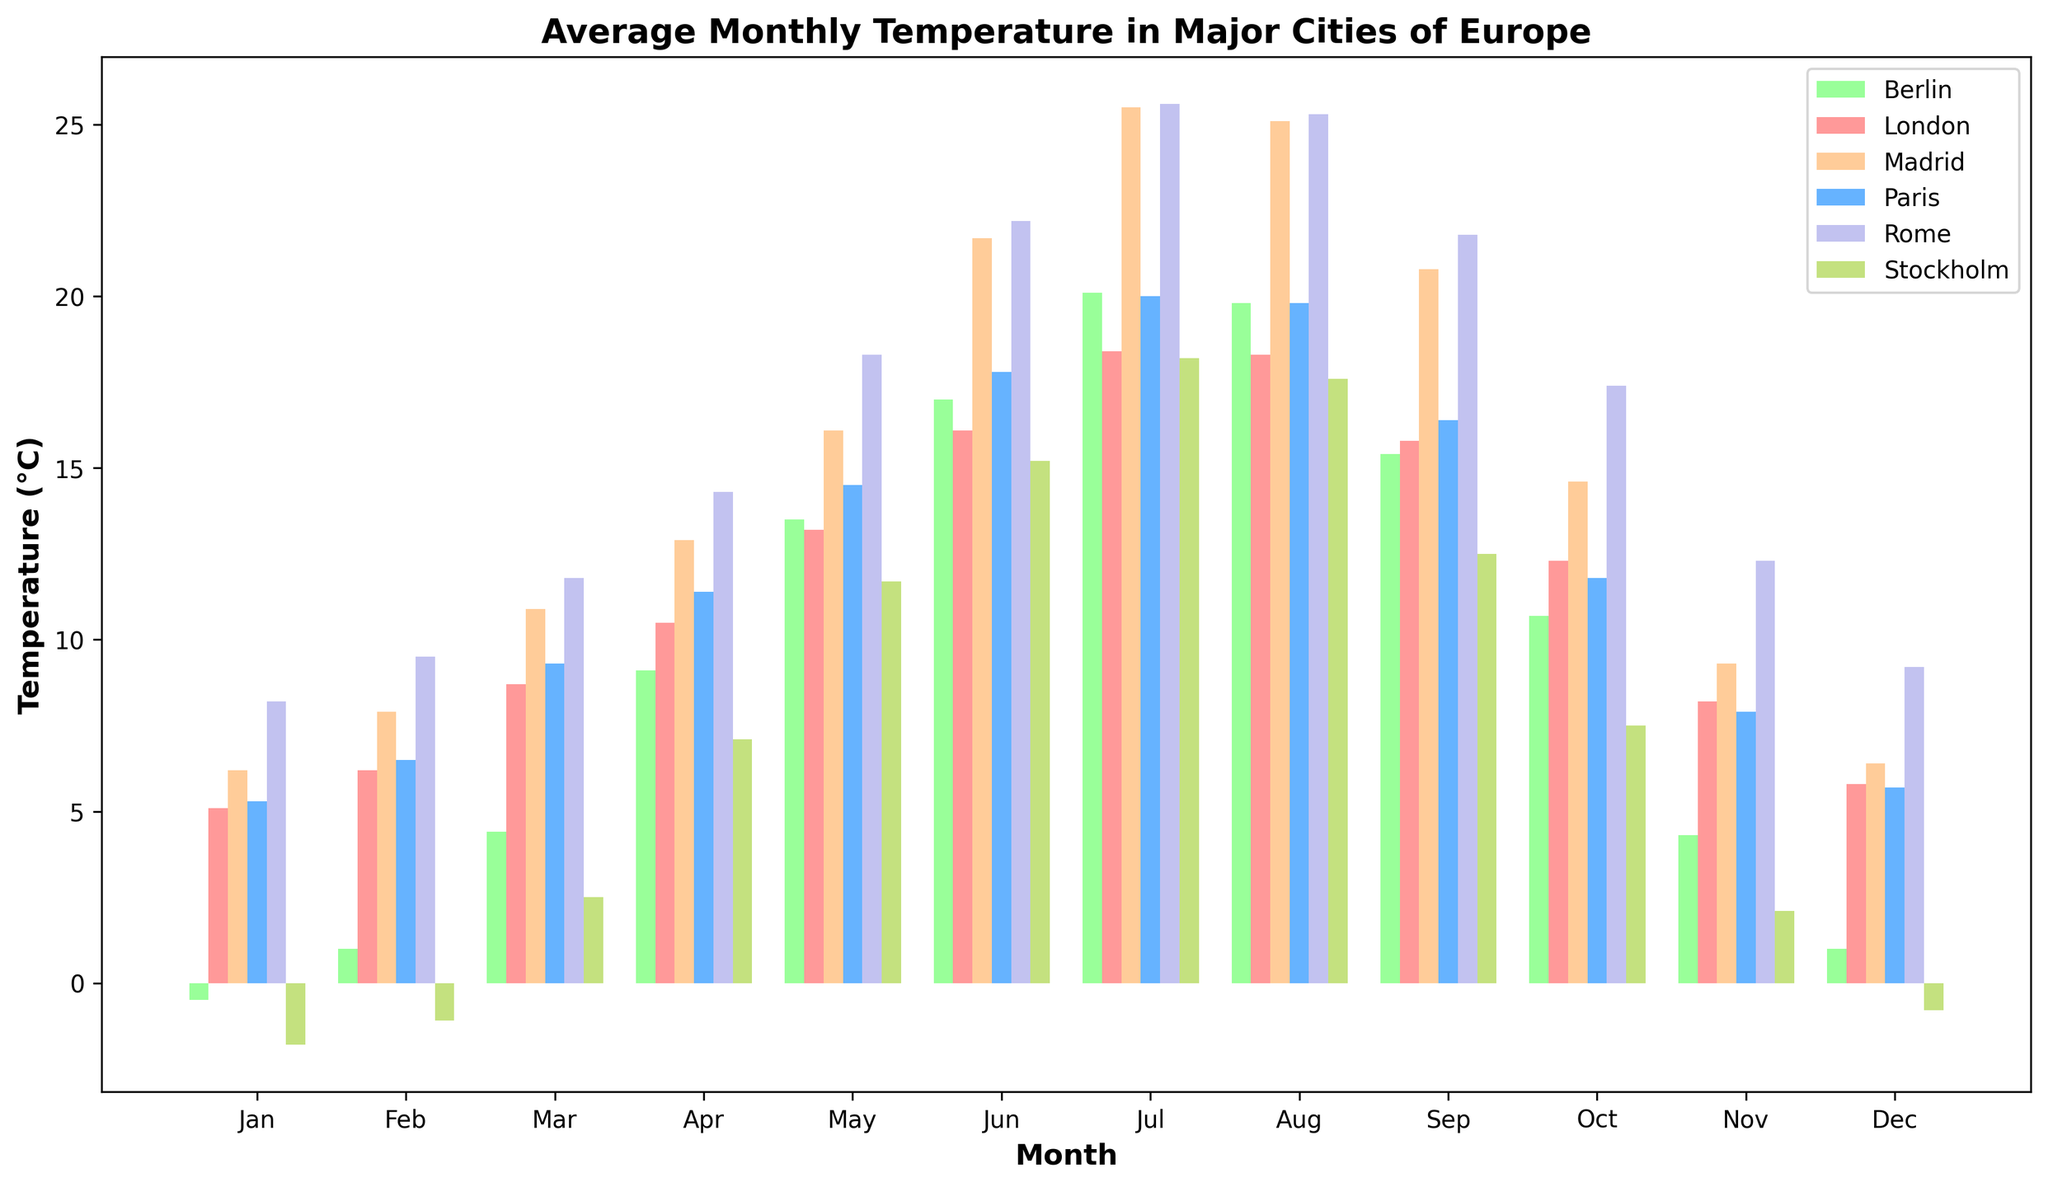What is the average temperature for Paris in the summer months (Jun, Jul, Aug)? To find the average temperature for Paris in the summer months, we sum the temperatures for June, July, and August (17.8+20.0+19.8) and then divide by the number of months (3). So the average temperature is (17.8+20.0+19.8)/3 = 19.2°C
Answer: 19.2°C Which city had the lowest temperature in January, and what was the temperature? Referring to the January temperatures on the plot, Stockholm had the lowest temperature at -1.8°C.
Answer: Stockholm, -1.8°C During which month is the temperature difference between Rome and Berlin the greatest? To find this, we look at the temperature difference between Rome and Berlin for each month on the plot and identify the month with the greatest gap. The largest difference is in January, where Rome is 8.2°C and Berlin is -0.5°C, resulting in a difference of 8.7°C.
Answer: January What's the average temperature in July for all cities combined? We add the July temperatures for each city and then divide by the total number of cities (6). [(18.4+20.0+20.1+25.5+25.6+18.2) / 6 = 127.8 / 6] So the answer is 21.3°C.
Answer: 21.3°C Which city shows the least variation in temperature over the year, and how can you tell? The city with the least temperature variation has the shortest bars in the chart. By scanning the chart, it's evident that London's temperatures vary the least across the months.
Answer: London In which month did Madrid have the highest temperature, and what was the temperature? By observing the heights of Madrid's bars, the highest temperature is in July, with a temperature of 25.5°C.
Answer: July, 25.5°C Was there any month where the temperature in Stockholm was higher than in any other city? If so, specify the month and cities. By comparing the heights of Stockholm’s bars with those of other cities in each month, we see that there was no month where Stockholm's temperature was the highest compared to all other cities.
Answer: No By approximately how much does the temperature in Rome increase from January to July? The temperature in Rome in January is 8.2°C, and in July, it is 25.6°C. The difference is 25.6 - 8.2 = 17.4°C.
Answer: 17.4°C Which city had the highest temperature in December, and what was the temperature? Observing the December bars, Rome had the highest temperature at 9.2°C.
Answer: Rome, 9.2°C 